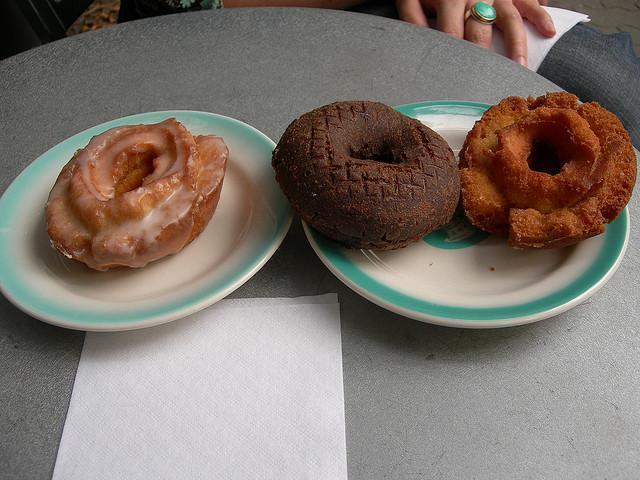How many donuts are picture?
Give a very brief answer. 3. How many chocolate donuts are there?
Give a very brief answer. 1. How many doughnuts are there?
Give a very brief answer. 3. How many donuts are pictured?
Give a very brief answer. 3. How many donuts are visible?
Give a very brief answer. 3. 